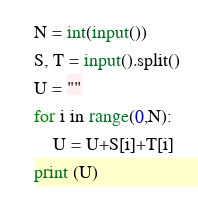<code> <loc_0><loc_0><loc_500><loc_500><_Python_>N = int(input())
S, T = input().split()
U = ""
for i in range(0,N):
    U = U+S[i]+T[i]
print (U)</code> 